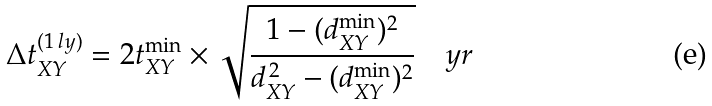<formula> <loc_0><loc_0><loc_500><loc_500>\Delta t _ { X Y } ^ { ( 1 \, l y ) } = 2 t _ { X Y } ^ { \min } \times \sqrt { \frac { 1 - ( d _ { X Y } ^ { \min } ) ^ { 2 } } { d _ { X Y } ^ { \, 2 } - ( d _ { X Y } ^ { \min } ) ^ { 2 } } } \quad y r</formula> 